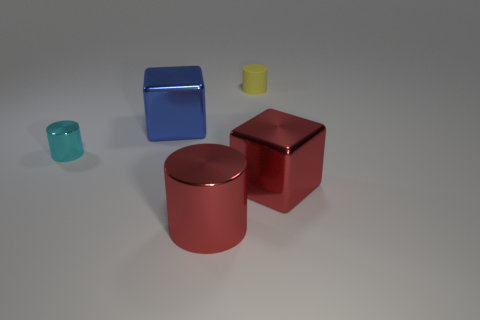What can we infer about the weight of these objects just by looking at them? Visually, the larger blue cube and red cube, along with the cylinder, appear to be the heaviest due to their solid, metallic look suggesting they are made out of a dense material such as metal. In contrast, the small bluish-green object looks like it's made of glass and is smaller in size, which typically would make it lighter. The small yellow object appears to be the lightest, possibly made of rubber or plastic, materials known for their light weight. 